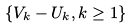<formula> <loc_0><loc_0><loc_500><loc_500>\{ V _ { k } - U _ { k } , k \geq 1 \}</formula> 